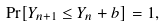<formula> <loc_0><loc_0><loc_500><loc_500>\Pr [ Y _ { n + 1 } \leq Y _ { n } + b ] = 1 ,</formula> 